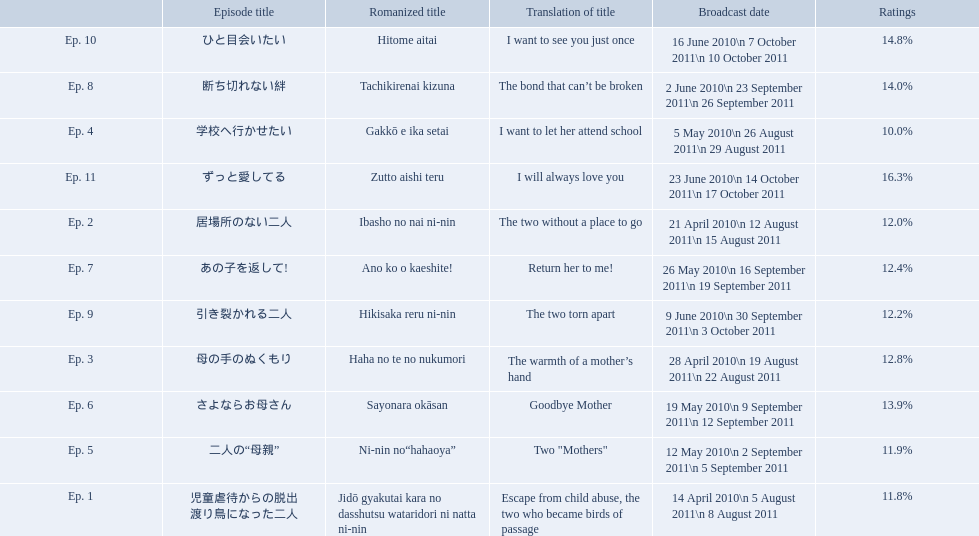How many total episodes are there? Ep. 1, Ep. 2, Ep. 3, Ep. 4, Ep. 5, Ep. 6, Ep. 7, Ep. 8, Ep. 9, Ep. 10, Ep. 11. Of those episodes, which one has the title of the bond that can't be broken? Ep. 8. What was the ratings percentage for that episode? 14.0%. Which episode had the highest ratings? Ep. 11. Which episode was named haha no te no nukumori? Ep. 3. Besides episode 10 which episode had a 14% rating? Ep. 8. Can you give me this table as a dict? {'header': ['', 'Episode title', 'Romanized title', 'Translation of title', 'Broadcast date', 'Ratings'], 'rows': [['Ep. 10', 'ひと目会いたい', 'Hitome aitai', 'I want to see you just once', '16 June 2010\\n 7 October 2011\\n 10 October 2011', '14.8%'], ['Ep. 8', '断ち切れない絆', 'Tachikirenai kizuna', 'The bond that can’t be broken', '2 June 2010\\n 23 September 2011\\n 26 September 2011', '14.0%'], ['Ep. 4', '学校へ行かせたい', 'Gakkō e ika setai', 'I want to let her attend school', '5 May 2010\\n 26 August 2011\\n 29 August 2011', '10.0%'], ['Ep. 11', 'ずっと愛してる', 'Zutto aishi teru', 'I will always love you', '23 June 2010\\n 14 October 2011\\n 17 October 2011', '16.3%'], ['Ep. 2', '居場所のない二人', 'Ibasho no nai ni-nin', 'The two without a place to go', '21 April 2010\\n 12 August 2011\\n 15 August 2011', '12.0%'], ['Ep. 7', 'あの子を返して!', 'Ano ko o kaeshite!', 'Return her to me!', '26 May 2010\\n 16 September 2011\\n 19 September 2011', '12.4%'], ['Ep. 9', '引き裂かれる二人', 'Hikisaka reru ni-nin', 'The two torn apart', '9 June 2010\\n 30 September 2011\\n 3 October 2011', '12.2%'], ['Ep. 3', '母の手のぬくもり', 'Haha no te no nukumori', 'The warmth of a mother’s hand', '28 April 2010\\n 19 August 2011\\n 22 August 2011', '12.8%'], ['Ep. 6', 'さよならお母さん', 'Sayonara okāsan', 'Goodbye Mother', '19 May 2010\\n 9 September 2011\\n 12 September 2011', '13.9%'], ['Ep. 5', '二人の“母親”', 'Ni-nin no“hahaoya”', 'Two "Mothers"', '12 May 2010\\n 2 September 2011\\n 5 September 2011', '11.9%'], ['Ep. 1', '児童虐待からの脱出 渡り鳥になった二人', 'Jidō gyakutai kara no dasshutsu wataridori ni natta ni-nin', 'Escape from child abuse, the two who became birds of passage', '14 April 2010\\n 5 August 2011\\n 8 August 2011', '11.8%']]} What are all of the episode numbers? Ep. 1, Ep. 2, Ep. 3, Ep. 4, Ep. 5, Ep. 6, Ep. 7, Ep. 8, Ep. 9, Ep. 10, Ep. 11. And their titles? 児童虐待からの脱出 渡り鳥になった二人, 居場所のない二人, 母の手のぬくもり, 学校へ行かせたい, 二人の“母親”, さよならお母さん, あの子を返して!, 断ち切れない絆, 引き裂かれる二人, ひと目会いたい, ずっと愛してる. What about their translated names? Escape from child abuse, the two who became birds of passage, The two without a place to go, The warmth of a mother’s hand, I want to let her attend school, Two "Mothers", Goodbye Mother, Return her to me!, The bond that can’t be broken, The two torn apart, I want to see you just once, I will always love you. Which episode number's title translated to i want to let her attend school? Ep. 4. 